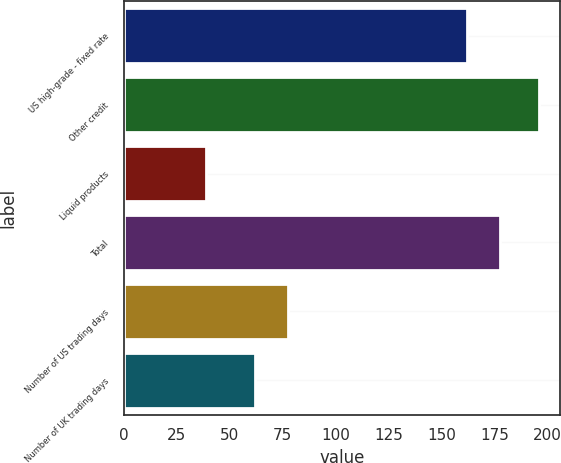Convert chart. <chart><loc_0><loc_0><loc_500><loc_500><bar_chart><fcel>US high-grade - fixed rate<fcel>Other credit<fcel>Liquid products<fcel>Total<fcel>Number of US trading days<fcel>Number of UK trading days<nl><fcel>162<fcel>196<fcel>39<fcel>177.7<fcel>77.7<fcel>62<nl></chart> 